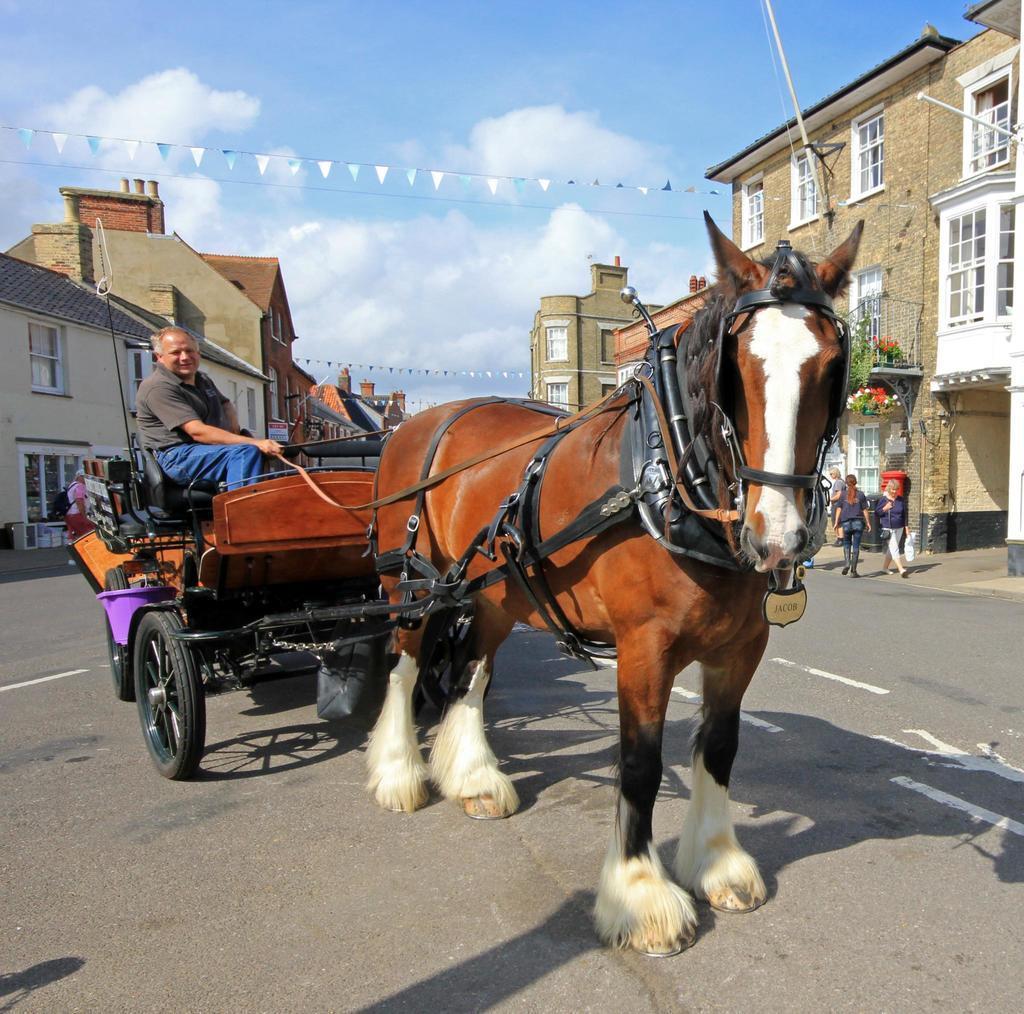Could you give a brief overview of what you see in this image? In this image there is a horse cart on a road, in that cart there is a man sitting, on either side of the road there are houses, in the background there is a blue sky. 